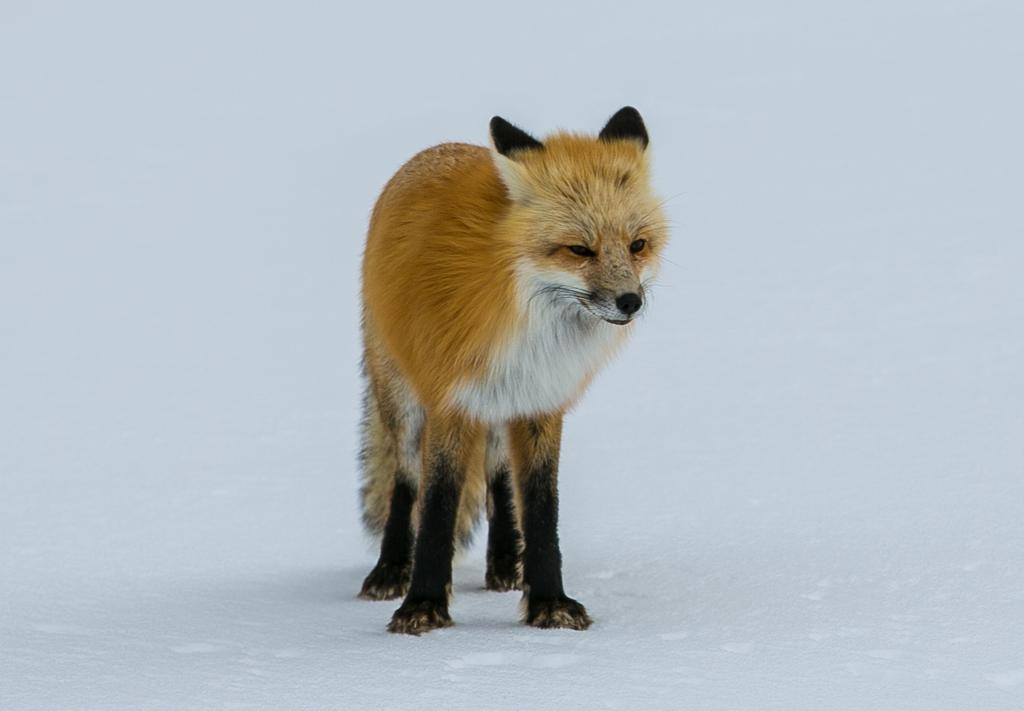What animal is present in the image? There is a fox in the image. What is the fox standing on in the image? The fox is on the snow. Who is the fox's aunt in the image? There is no mention of an aunt or any family relationships in the image. The image only features a fox standing on the snow. 